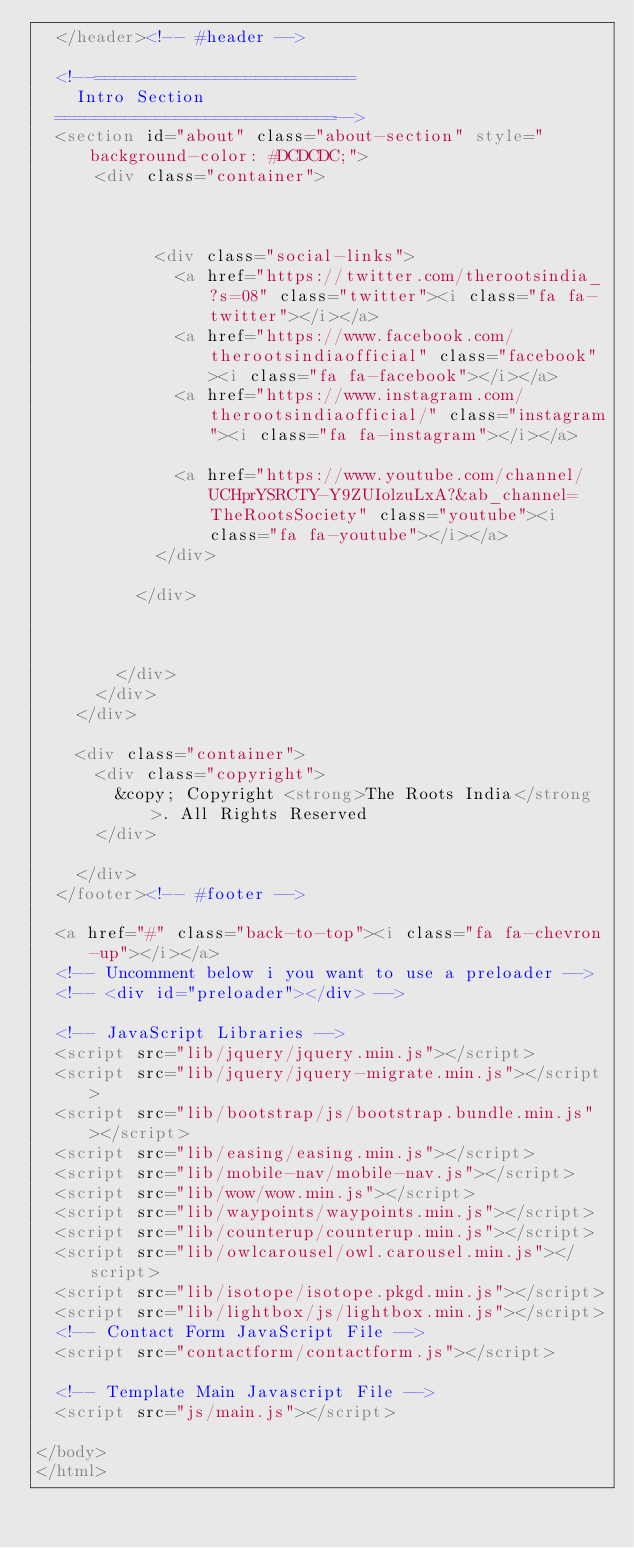Convert code to text. <code><loc_0><loc_0><loc_500><loc_500><_HTML_>  </header><!-- #header -->

  <!--==========================
    Intro Section
  ============================-->
  <section id="about" class="about-section" style="background-color: #DCDCDC;">
      <div class="container">
        
           

            <div class="social-links">
              <a href="https://twitter.com/therootsindia_?s=08" class="twitter"><i class="fa fa-twitter"></i></a>
              <a href="https://www.facebook.com/therootsindiaofficial" class="facebook"><i class="fa fa-facebook"></i></a>
              <a href="https://www.instagram.com/therootsindiaofficial/" class="instagram"><i class="fa fa-instagram"></i></a>
              
              <a href="https://www.youtube.com/channel/UCHprYSRCTY-Y9ZUIolzuLxA?&ab_channel=TheRootsSociety" class="youtube"><i class="fa fa-youtube"></i></a>
            </div>

          </div>

          

        </div>
      </div>
    </div>

    <div class="container">
      <div class="copyright">
        &copy; Copyright <strong>The Roots India</strong>. All Rights Reserved
      </div>
      
    </div>
  </footer><!-- #footer -->

  <a href="#" class="back-to-top"><i class="fa fa-chevron-up"></i></a>
  <!-- Uncomment below i you want to use a preloader -->
  <!-- <div id="preloader"></div> -->

  <!-- JavaScript Libraries -->
  <script src="lib/jquery/jquery.min.js"></script>
  <script src="lib/jquery/jquery-migrate.min.js"></script>
  <script src="lib/bootstrap/js/bootstrap.bundle.min.js"></script>
  <script src="lib/easing/easing.min.js"></script>
  <script src="lib/mobile-nav/mobile-nav.js"></script>
  <script src="lib/wow/wow.min.js"></script>
  <script src="lib/waypoints/waypoints.min.js"></script>
  <script src="lib/counterup/counterup.min.js"></script>
  <script src="lib/owlcarousel/owl.carousel.min.js"></script>
  <script src="lib/isotope/isotope.pkgd.min.js"></script>
  <script src="lib/lightbox/js/lightbox.min.js"></script>
  <!-- Contact Form JavaScript File -->
  <script src="contactform/contactform.js"></script>

  <!-- Template Main Javascript File -->
  <script src="js/main.js"></script>

</body>
</html>
</code> 